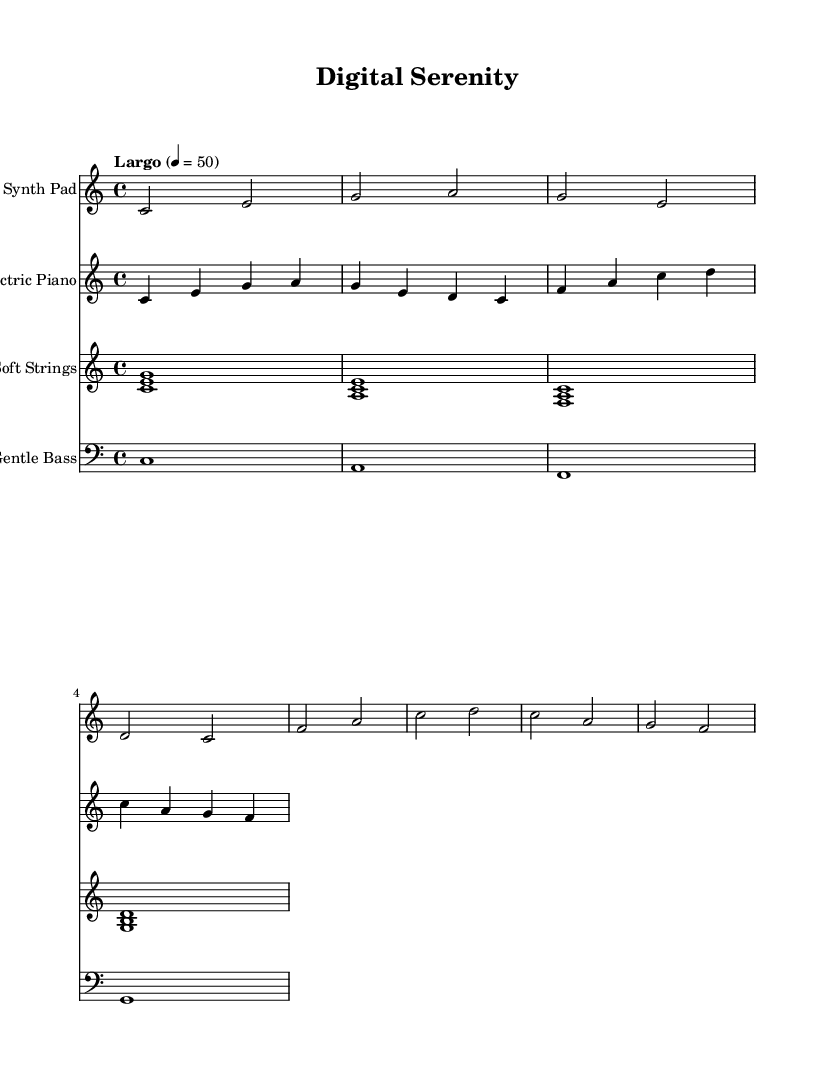What is the key signature of this music? The key signature is indicated at the beginning of the staff. It shows no sharps or flats, which means the key is C major.
Answer: C major What is the time signature of this music? The time signature is also found at the beginning of the score, showing 4 over 4, which indicates that there are four beats in each measure.
Answer: 4/4 What is the tempo marking for this piece? The tempo marking is specified in the score, indicating the pace of the music. It is marked as "Largo," which usually means it should be played slowly.
Answer: Largo How many measures are in the Synth Pad staff? To find the number of measures, we count the vertical lines (bar lines) in the Synth Pad staff. There are four measures visible from the score.
Answer: 4 Which instrument has the lowest pitch in this arrangement? The Gentle Bass usually plays in the lower register, and by observing the clef and the notes played, it is clear that it has the lowest pitch compared to the other instruments.
Answer: Gentle Bass What type of harmony is primarily used in the Soft Strings part? The chords used in the Soft Strings part are built from multiple notes played together, typical of triads, indicating a harmonic texture that exemplifies ambient soundscapes.
Answer: Triads What is the overall dynamic style suggested by the tempo and instrumentation? Considering the slow tempo and the chosen instruments (Synth Pad, Electric Piano, Soft Strings, and Gentle Bass), the dynamic style suggests a calm and serene atmosphere conducive to focus and problem-solving.
Answer: Calm 